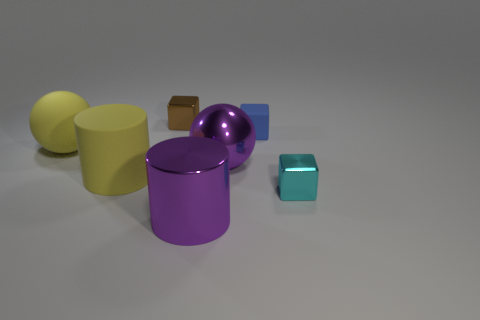What is the material of the big purple sphere?
Provide a short and direct response. Metal. What is the color of the metal cube that is in front of the small brown metallic cube?
Your answer should be compact. Cyan. How many matte cylinders are the same color as the big rubber sphere?
Your answer should be compact. 1. What number of objects are behind the big yellow cylinder and on the right side of the yellow rubber cylinder?
Offer a very short reply. 3. The rubber thing that is the same size as the yellow ball is what shape?
Provide a succinct answer. Cylinder. The purple sphere is what size?
Your answer should be very brief. Large. There is a cube on the left side of the purple cylinder that is in front of the shiny cube that is to the right of the brown block; what is its material?
Your answer should be compact. Metal. There is a cylinder that is made of the same material as the brown thing; what color is it?
Your answer should be compact. Purple. How many big yellow objects are on the left side of the cylinder that is to the left of the big purple object that is in front of the tiny cyan cube?
Your response must be concise. 1. There is a big cylinder that is the same color as the matte ball; what material is it?
Offer a terse response. Rubber. 